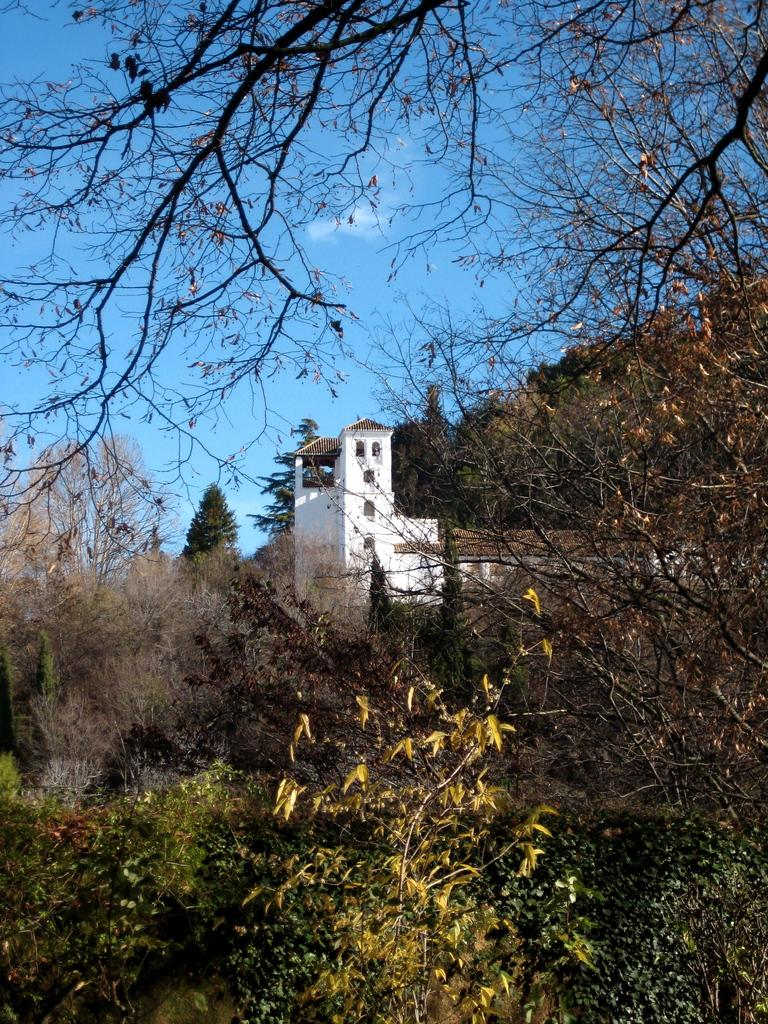What type of natural elements can be seen in the picture? There are trees in the picture. What structure is located in the middle of the picture? There is a building in the middle of the picture. What feature of the building is mentioned in the facts? The building has windows. What can be seen in the background of the picture? There is a sky visible in the background. What weather condition can be inferred from the background? There are clouds in the sky, suggesting a partly cloudy day. What type of finger can be seen holding a potato in the image? There is no finger or potato present in the image. Is there a fire visible in the image? No, there is no fire visible in the image. 